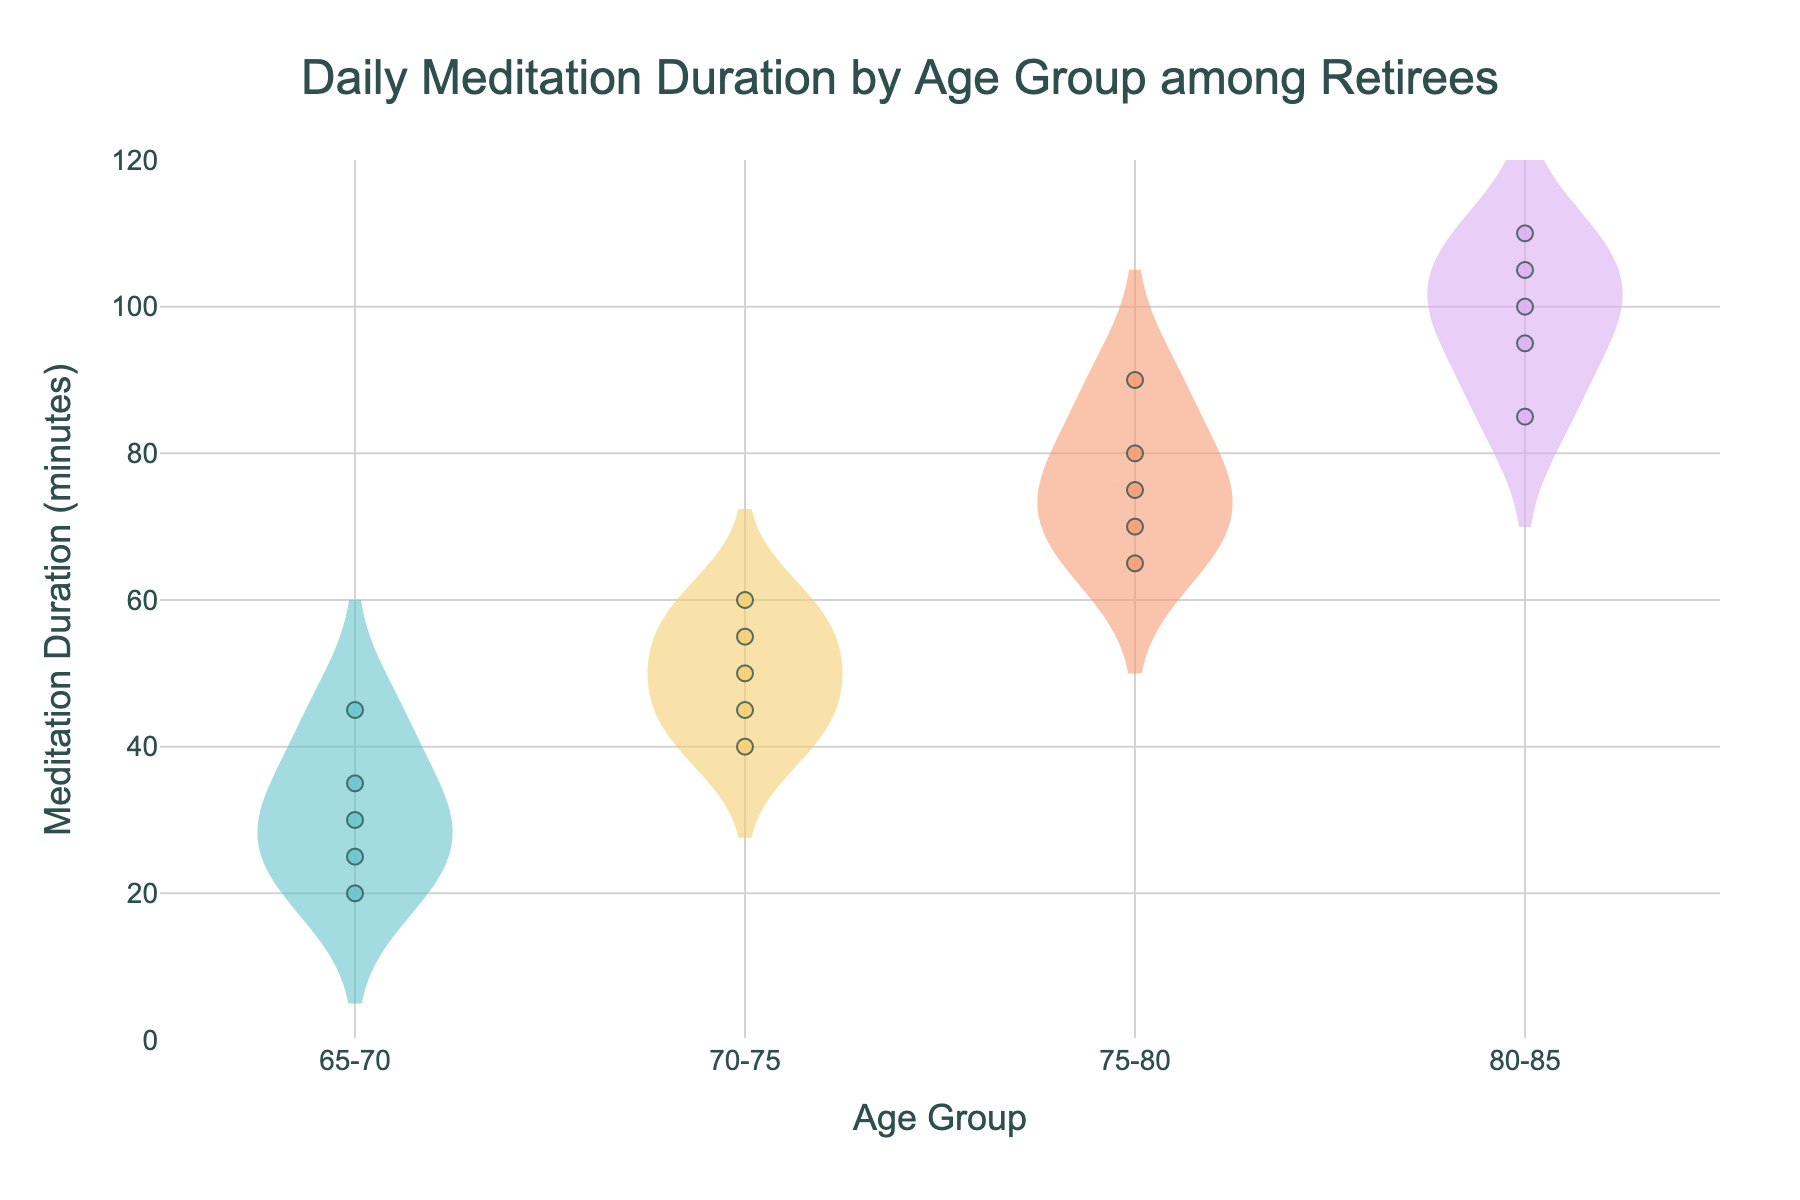How many age groups are shown in the plot? The plot has distinct distributions assigned to each age group, and their count can be determined by looking at the x-axis where the age groups are labeled.
Answer: 4 What is the title of the plot? The title is usually positioned at the top of the plot to inform the viewer about the subject of the visualization.
Answer: Daily Meditation Duration by Age Group among Retirees Which age group has the highest median meditation duration? By examining the violin plots, the median can be found at the central horizontal line visible within each distribution. The 80-85 age group shows the highest median near the center of the vertical distribution.
Answer: 80-85 What is the range of meditation durations for the 75-80 age group? The range can be identified by finding the minimum and maximum values in the violin plot for this group. The plot shows the lowest value around 65 minutes and the highest around 90 minutes.
Answer: 65 to 90 minutes Compare the meditation durations in the 70-75 and 80-85 age groups. Which group shows greater variability? Variability can be inferred from the spread and shape of the violin plots. The 80-85 age group appears to have a wider distribution (ranging from 85 to 110 minutes) compared to the 70-75 age group (ranging from 40 to 60 minutes).
Answer: 80-85 What is the average meditation duration for the 70-75 age group? First, sum the durations: 40 + 60 + 50 + 55 + 45 = 250. Then, divide by the number of data points: 250 / 5. This can be easily read or computed from the plot's displayed data points.
Answer: 50 minutes Are there any outliers in the 80-85 age group? Outliers can be seen as points that lie distinctly away from the bulk of data in the plot. In the 80-85 group's distribution, all points seem close to each other without significant deviation.
Answer: No Which age group has the smallest median meditation duration? To find the smallest median, compare the median lines (central lines within the distributions). The 65-70 age group shows the smallest median around 30 minutes.
Answer: 65-70 How does the meditation duration in the 75-80 age group compare to the 65-70 age group? By comparing the outlines and centers of the violin plots, the 75-80 age group has generally higher values and a higher median than the 65-70 group.
Answer: Higher 